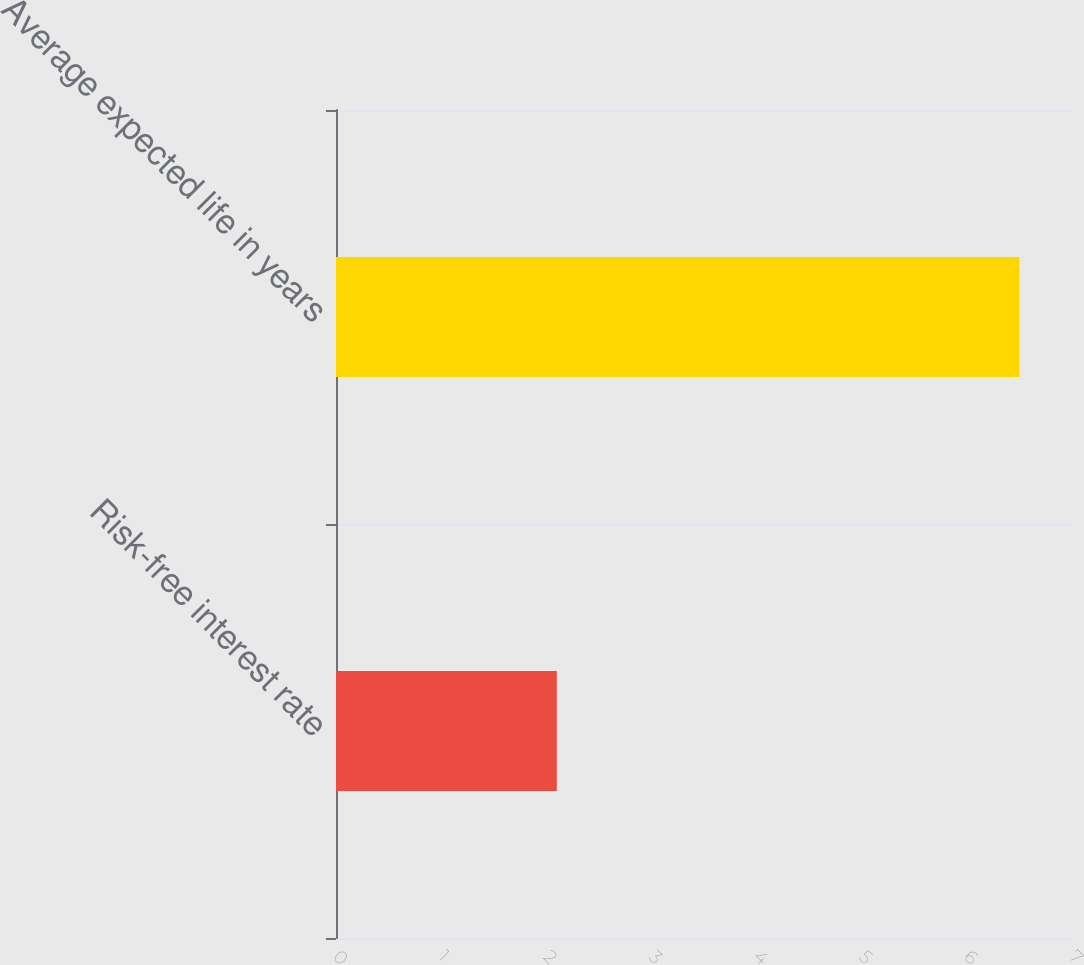Convert chart. <chart><loc_0><loc_0><loc_500><loc_500><bar_chart><fcel>Risk-free interest rate<fcel>Average expected life in years<nl><fcel>2.1<fcel>6.5<nl></chart> 